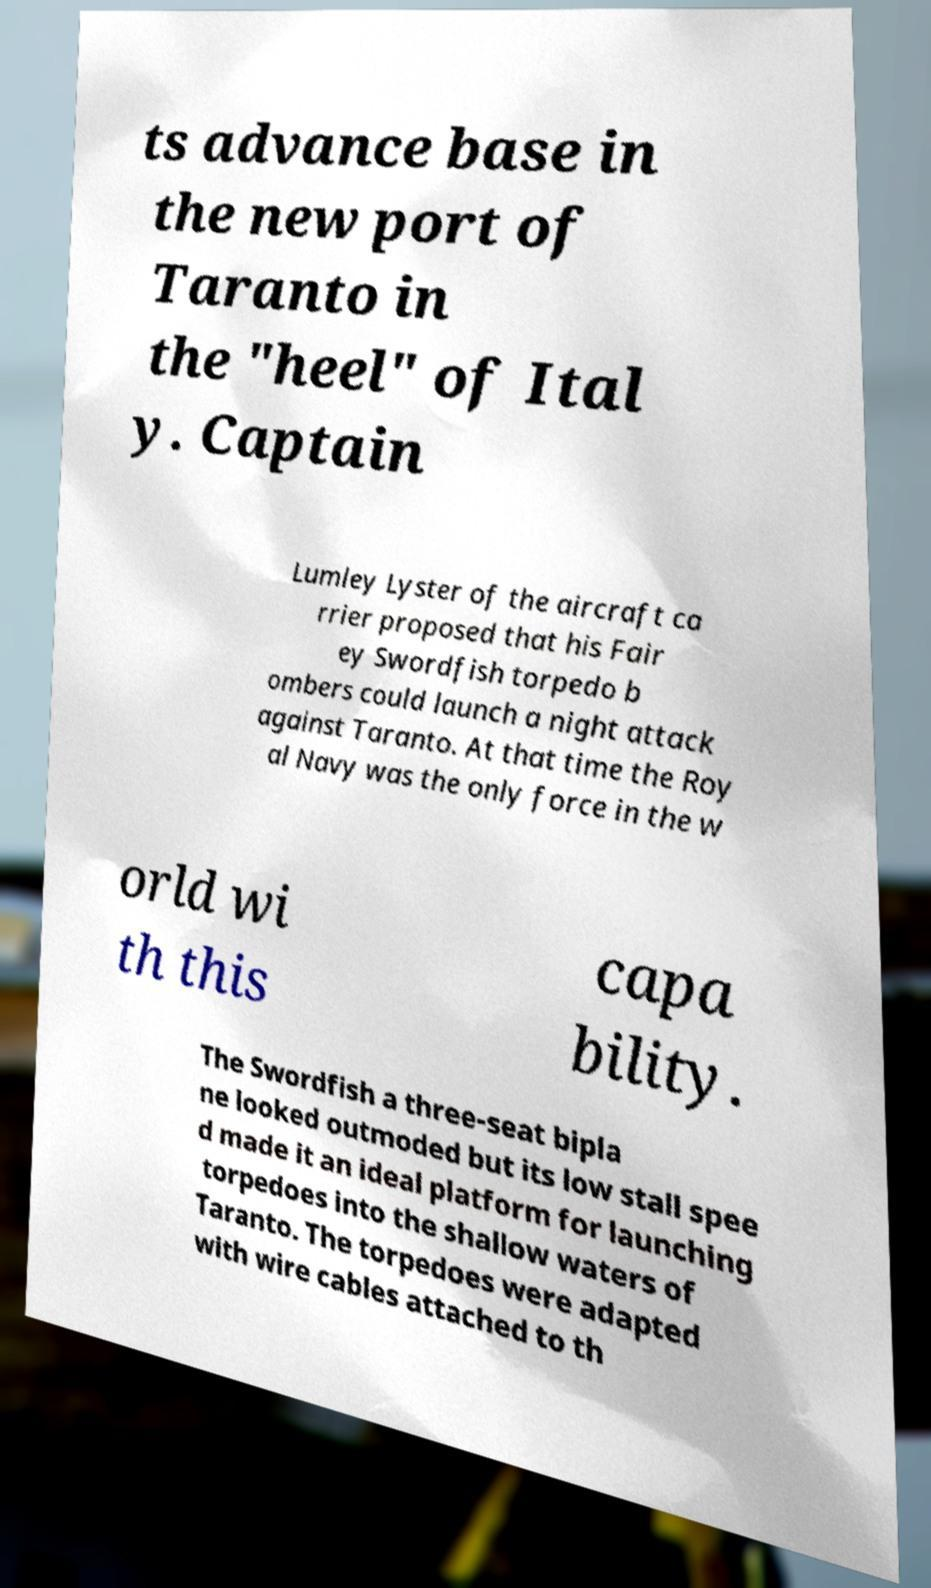There's text embedded in this image that I need extracted. Can you transcribe it verbatim? ts advance base in the new port of Taranto in the "heel" of Ital y. Captain Lumley Lyster of the aircraft ca rrier proposed that his Fair ey Swordfish torpedo b ombers could launch a night attack against Taranto. At that time the Roy al Navy was the only force in the w orld wi th this capa bility. The Swordfish a three-seat bipla ne looked outmoded but its low stall spee d made it an ideal platform for launching torpedoes into the shallow waters of Taranto. The torpedoes were adapted with wire cables attached to th 